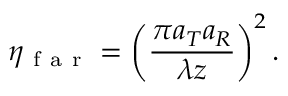<formula> <loc_0><loc_0><loc_500><loc_500>\eta _ { f a r } = \left ( \frac { \pi a _ { T } a _ { R } } { \lambda z } \right ) ^ { 2 } .</formula> 